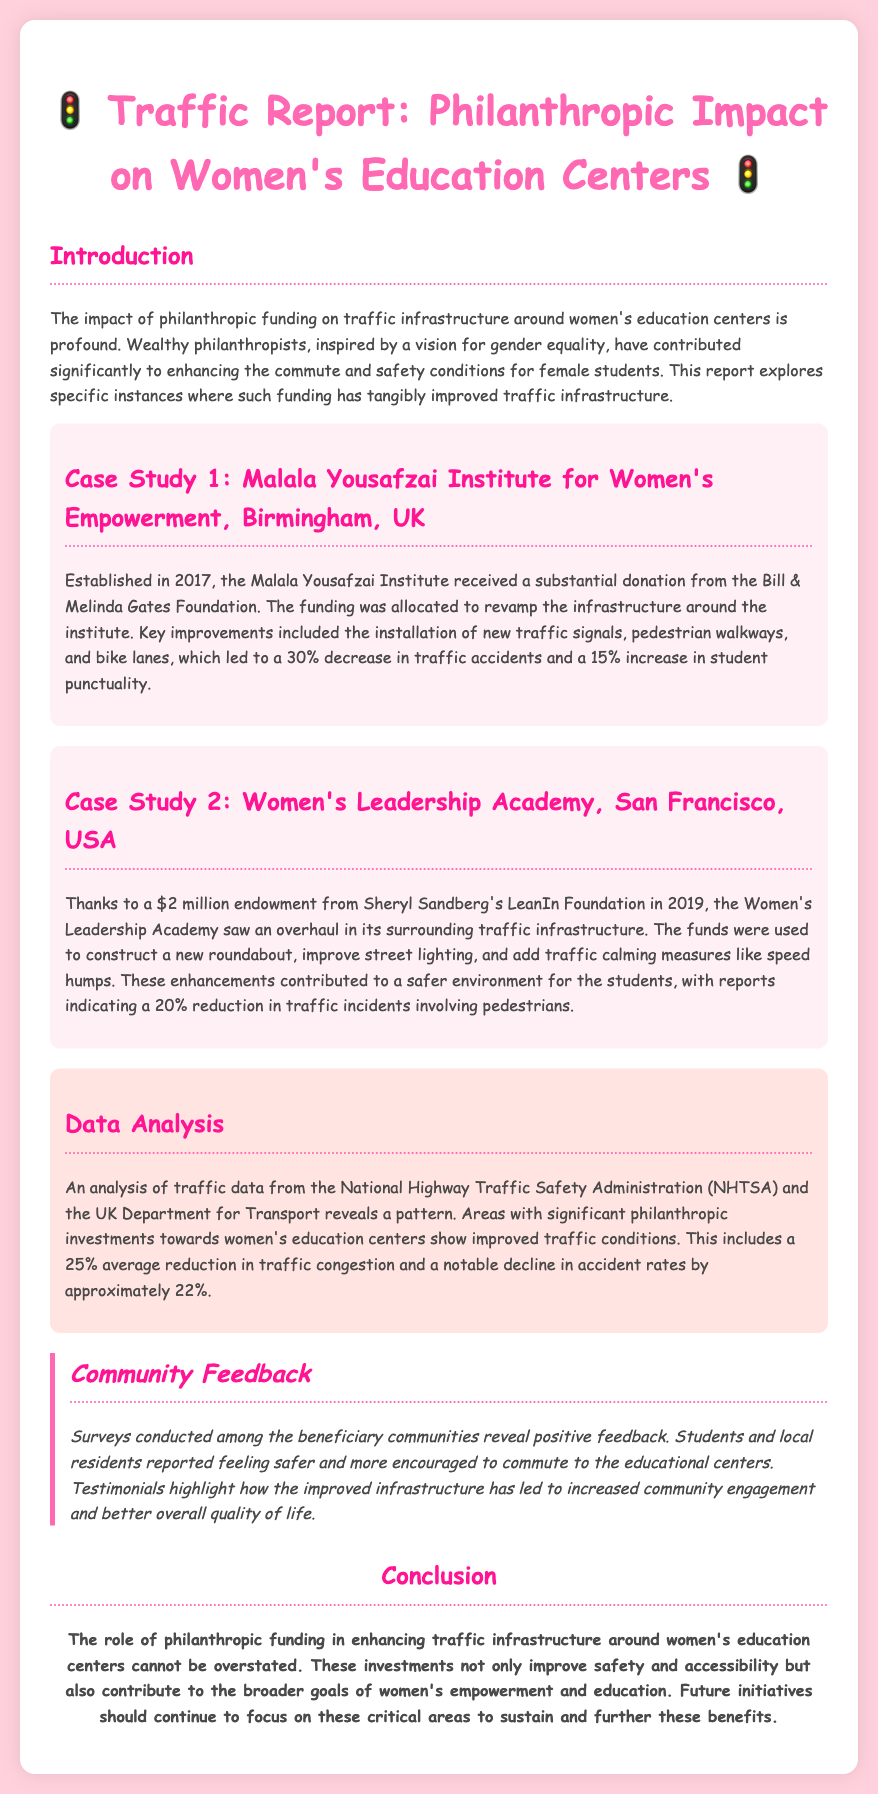What is the name of the first institute mentioned? The first institute mentioned in the report is the Malala Yousafzai Institute for Women's Empowerment.
Answer: Malala Yousafzai Institute for Women's Empowerment How much funding did the Women's Leadership Academy receive? The Women's Leadership Academy received a $2 million endowment from the LeanIn Foundation.
Answer: $2 million What percentage decrease in traffic accidents was reported for the Malala Yousafzai Institute? The report states a 30% decrease in traffic accidents after the improvements.
Answer: 30% What year was the Malala Yousafzai Institute established? The Malala Yousafzai Institute was established in 2017.
Answer: 2017 What is the average percentage reduction in traffic congestion reported? The document mentions a 25% average reduction in traffic congestion in areas with philanthropic investments.
Answer: 25% Which foundation provided funding for the Malala Yousafzai Institute? The funding for the Malala Yousafzai Institute was provided by the Bill & Melinda Gates Foundation.
Answer: Bill & Melinda Gates Foundation What year did the Women's Leadership Academy receive its funding? The Women's Leadership Academy received its funding in 2019.
Answer: 2019 What is the main focus of the report? The main focus of the report is the impact of philanthropic funding on traffic infrastructure around women's education centers.
Answer: Impact of philanthropic funding on traffic infrastructure 